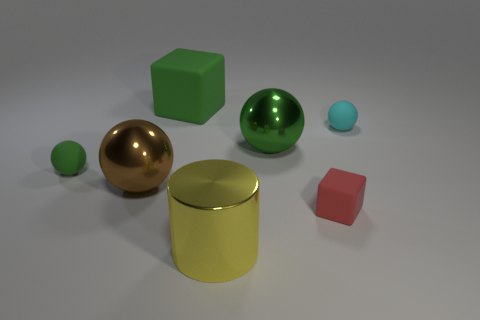Subtract 1 spheres. How many spheres are left? 3 Subtract all cyan cylinders. Subtract all purple balls. How many cylinders are left? 1 Add 1 small green things. How many objects exist? 8 Subtract all spheres. How many objects are left? 3 Add 6 big brown metallic things. How many big brown metallic things exist? 7 Subtract 0 gray spheres. How many objects are left? 7 Subtract all big brown balls. Subtract all tiny cyan things. How many objects are left? 5 Add 3 small red matte things. How many small red matte things are left? 4 